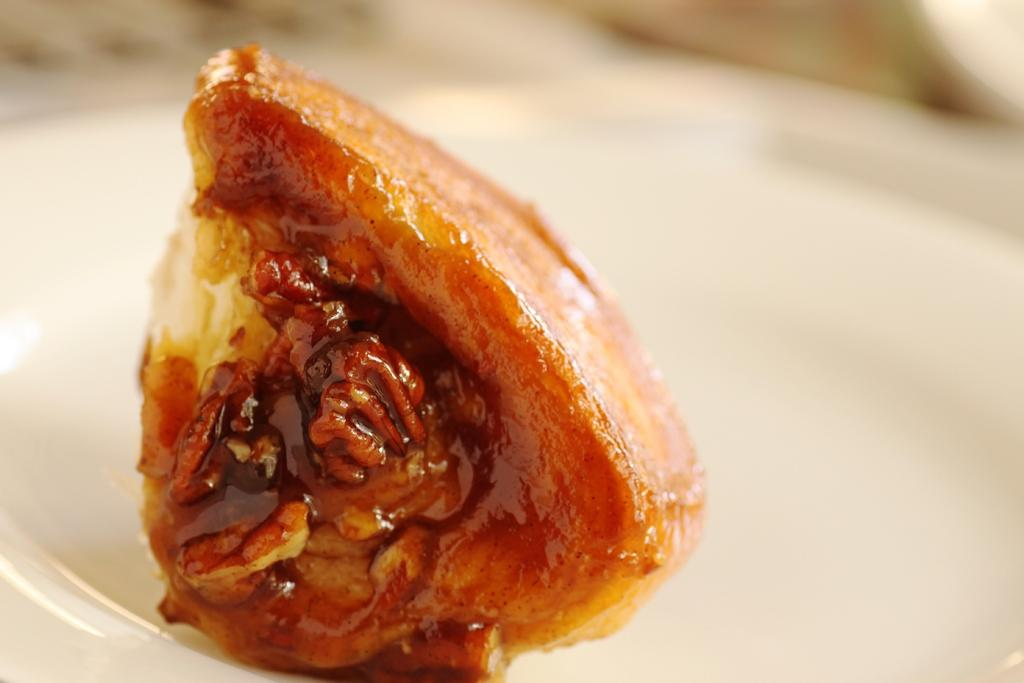What is the main object in the center of the image? There is a table in the center of the image. What is placed on the table? There is a plate on the table. What is on the plate? There is a food item on the plate. Can you describe the background of the image? The background of the image is blurred. What type of guitar can be seen in the image? There is no guitar present in the image. How many trucks are visible in the image? There are no trucks visible in the image. 